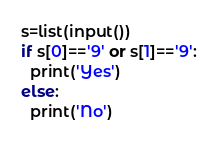Convert code to text. <code><loc_0><loc_0><loc_500><loc_500><_Python_>s=list(input())
if s[0]=='9' or s[1]=='9':
  print('Yes')
else:
  print('No')</code> 